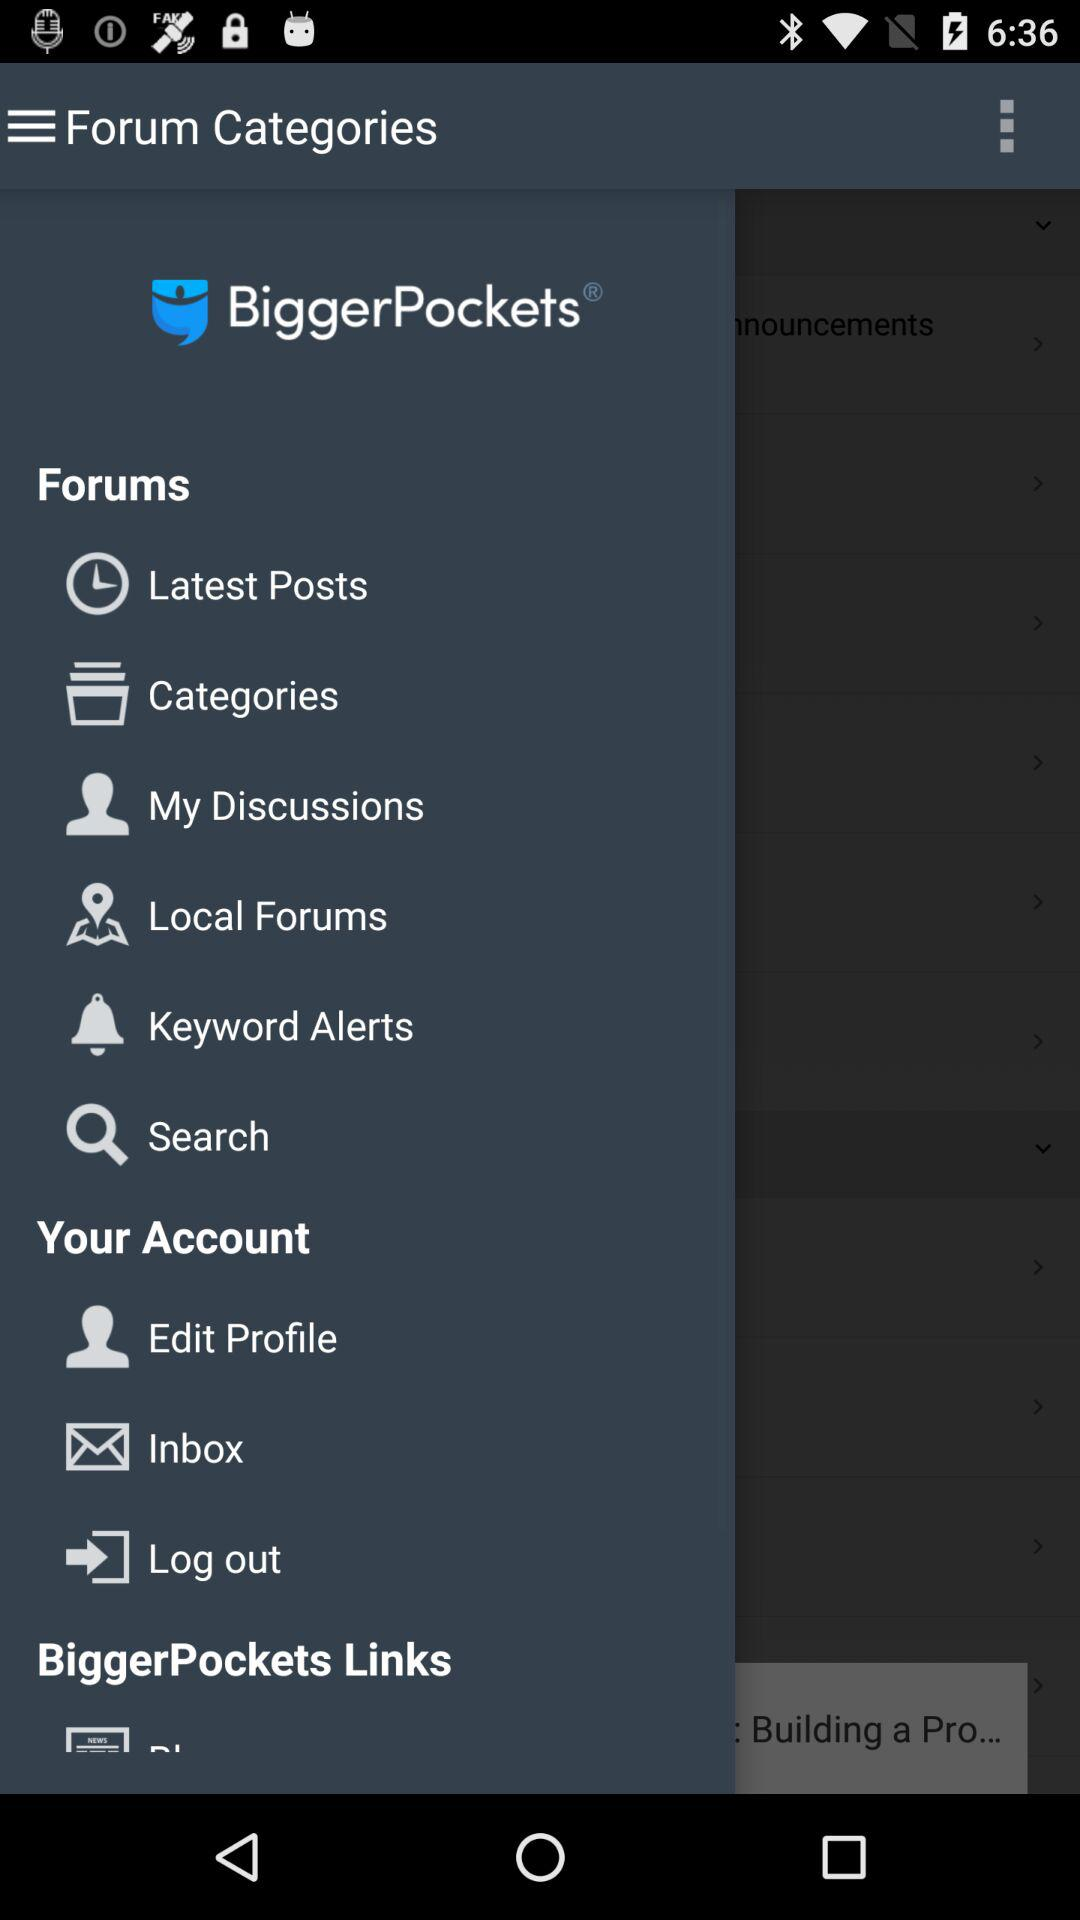When was the latest post posted?
When the provided information is insufficient, respond with <no answer>. <no answer> 